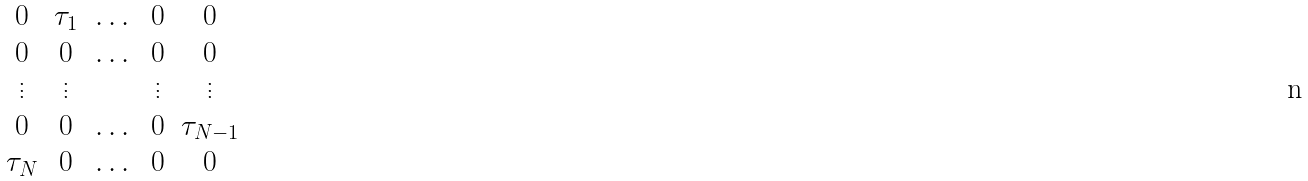<formula> <loc_0><loc_0><loc_500><loc_500>\begin{matrix} 0 & \tau _ { 1 } & \dots & 0 & 0 \\ 0 & 0 & \dots & 0 & 0 \\ \vdots & \vdots & & \vdots & \vdots \\ 0 & 0 & \dots & 0 & \tau _ { N - 1 } \\ \tau _ { N } & 0 & \dots & 0 & 0 \end{matrix}</formula> 